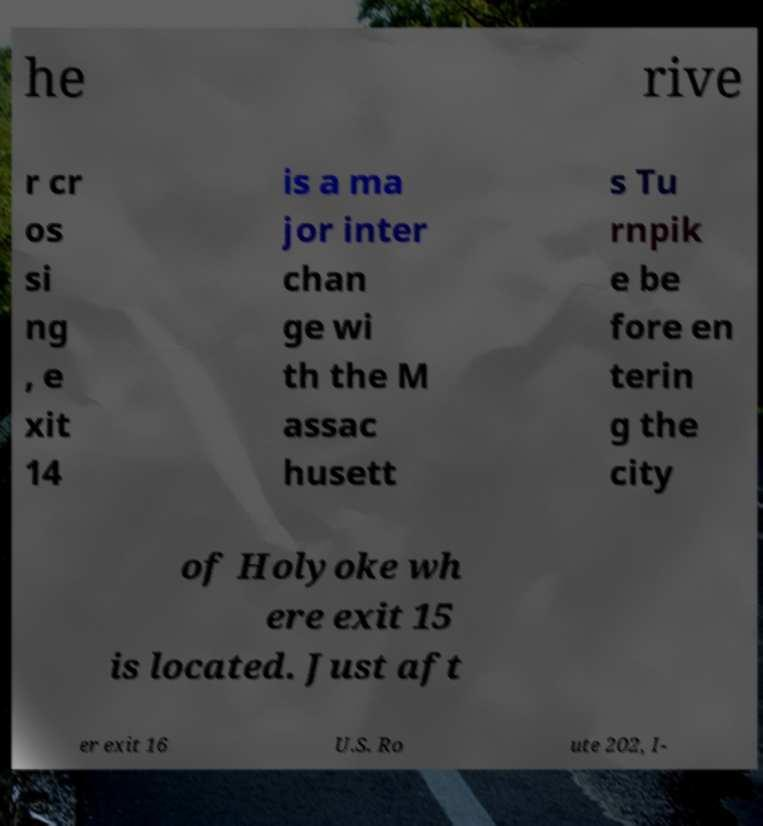Please identify and transcribe the text found in this image. he rive r cr os si ng , e xit 14 is a ma jor inter chan ge wi th the M assac husett s Tu rnpik e be fore en terin g the city of Holyoke wh ere exit 15 is located. Just aft er exit 16 U.S. Ro ute 202, I- 